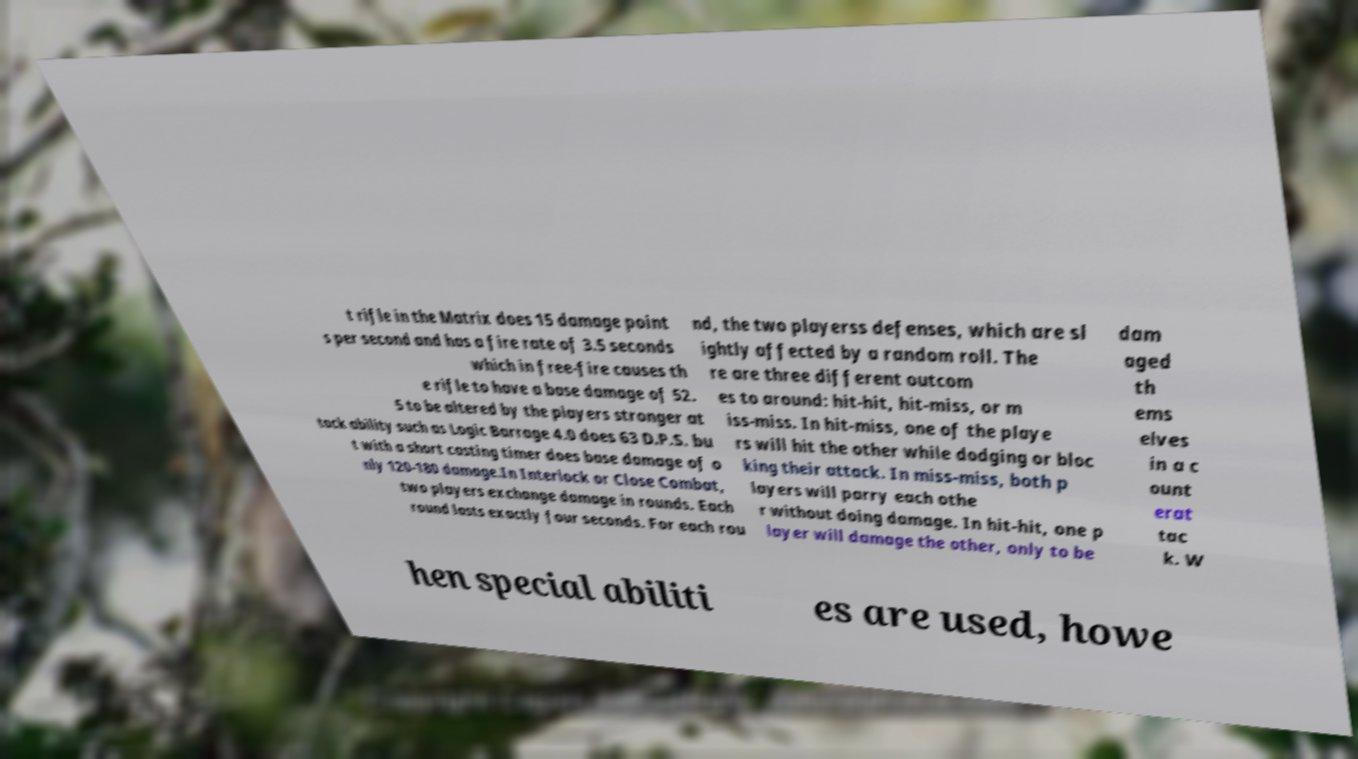Can you read and provide the text displayed in the image?This photo seems to have some interesting text. Can you extract and type it out for me? t rifle in the Matrix does 15 damage point s per second and has a fire rate of 3.5 seconds which in free-fire causes th e rifle to have a base damage of 52. 5 to be altered by the players stronger at tack ability such as Logic Barrage 4.0 does 63 D.P.S. bu t with a short casting timer does base damage of o nly 120-180 damage.In Interlock or Close Combat, two players exchange damage in rounds. Each round lasts exactly four seconds. For each rou nd, the two playerss defenses, which are sl ightly affected by a random roll. The re are three different outcom es to around: hit-hit, hit-miss, or m iss-miss. In hit-miss, one of the playe rs will hit the other while dodging or bloc king their attack. In miss-miss, both p layers will parry each othe r without doing damage. In hit-hit, one p layer will damage the other, only to be dam aged th ems elves in a c ount erat tac k. W hen special abiliti es are used, howe 